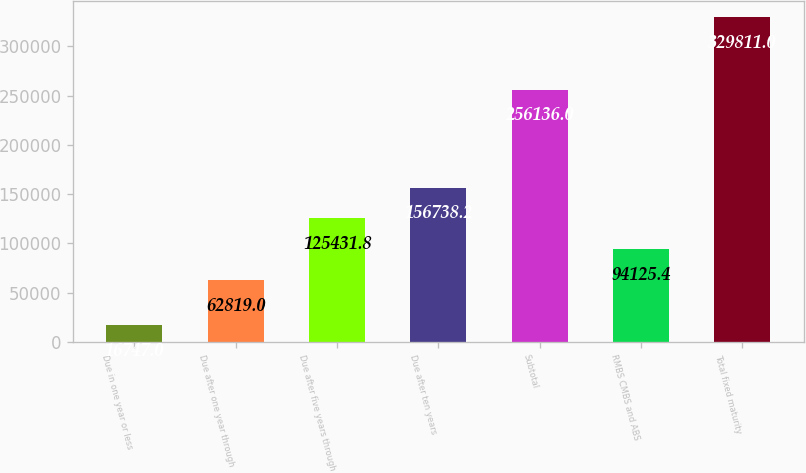Convert chart to OTSL. <chart><loc_0><loc_0><loc_500><loc_500><bar_chart><fcel>Due in one year or less<fcel>Due after one year through<fcel>Due after five years through<fcel>Due after ten years<fcel>Subtotal<fcel>RMBS CMBS and ABS<fcel>Total fixed maturity<nl><fcel>16747<fcel>62819<fcel>125432<fcel>156738<fcel>256136<fcel>94125.4<fcel>329811<nl></chart> 